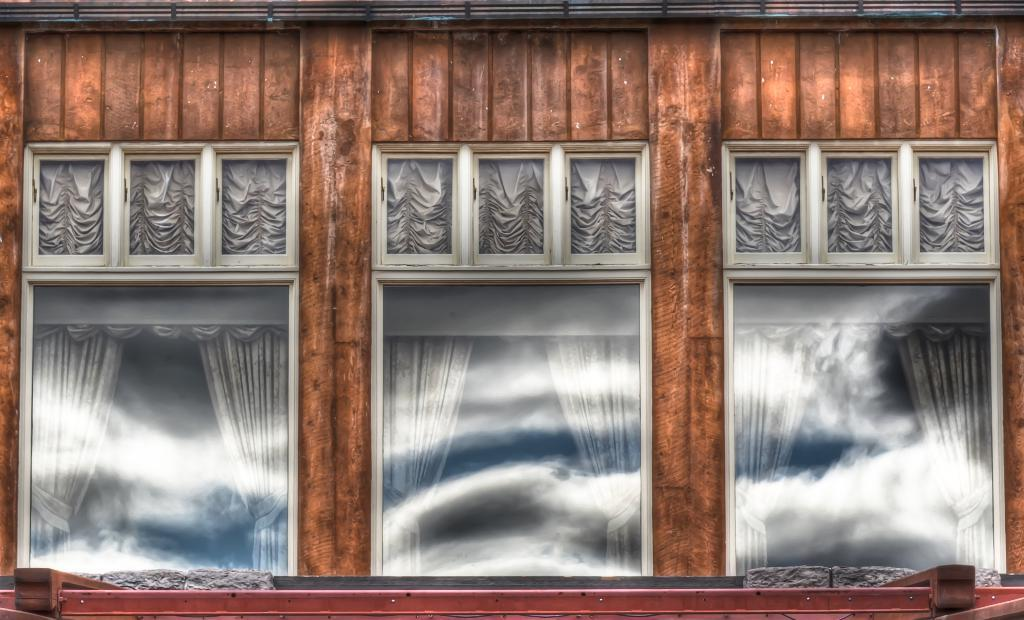What type of structure is visible in the image? There is a building wall in the image. What can be seen on the building wall? There are windows in the image. Are there any window treatments visible in the image? Yes, there are curtains in the image. What time of day might the image have been taken? The image was likely taken during the day, as there is sufficient light to see the details. What fact was recorded in the image? There is no fact being recorded in the image; it is a static photograph of a building wall. 